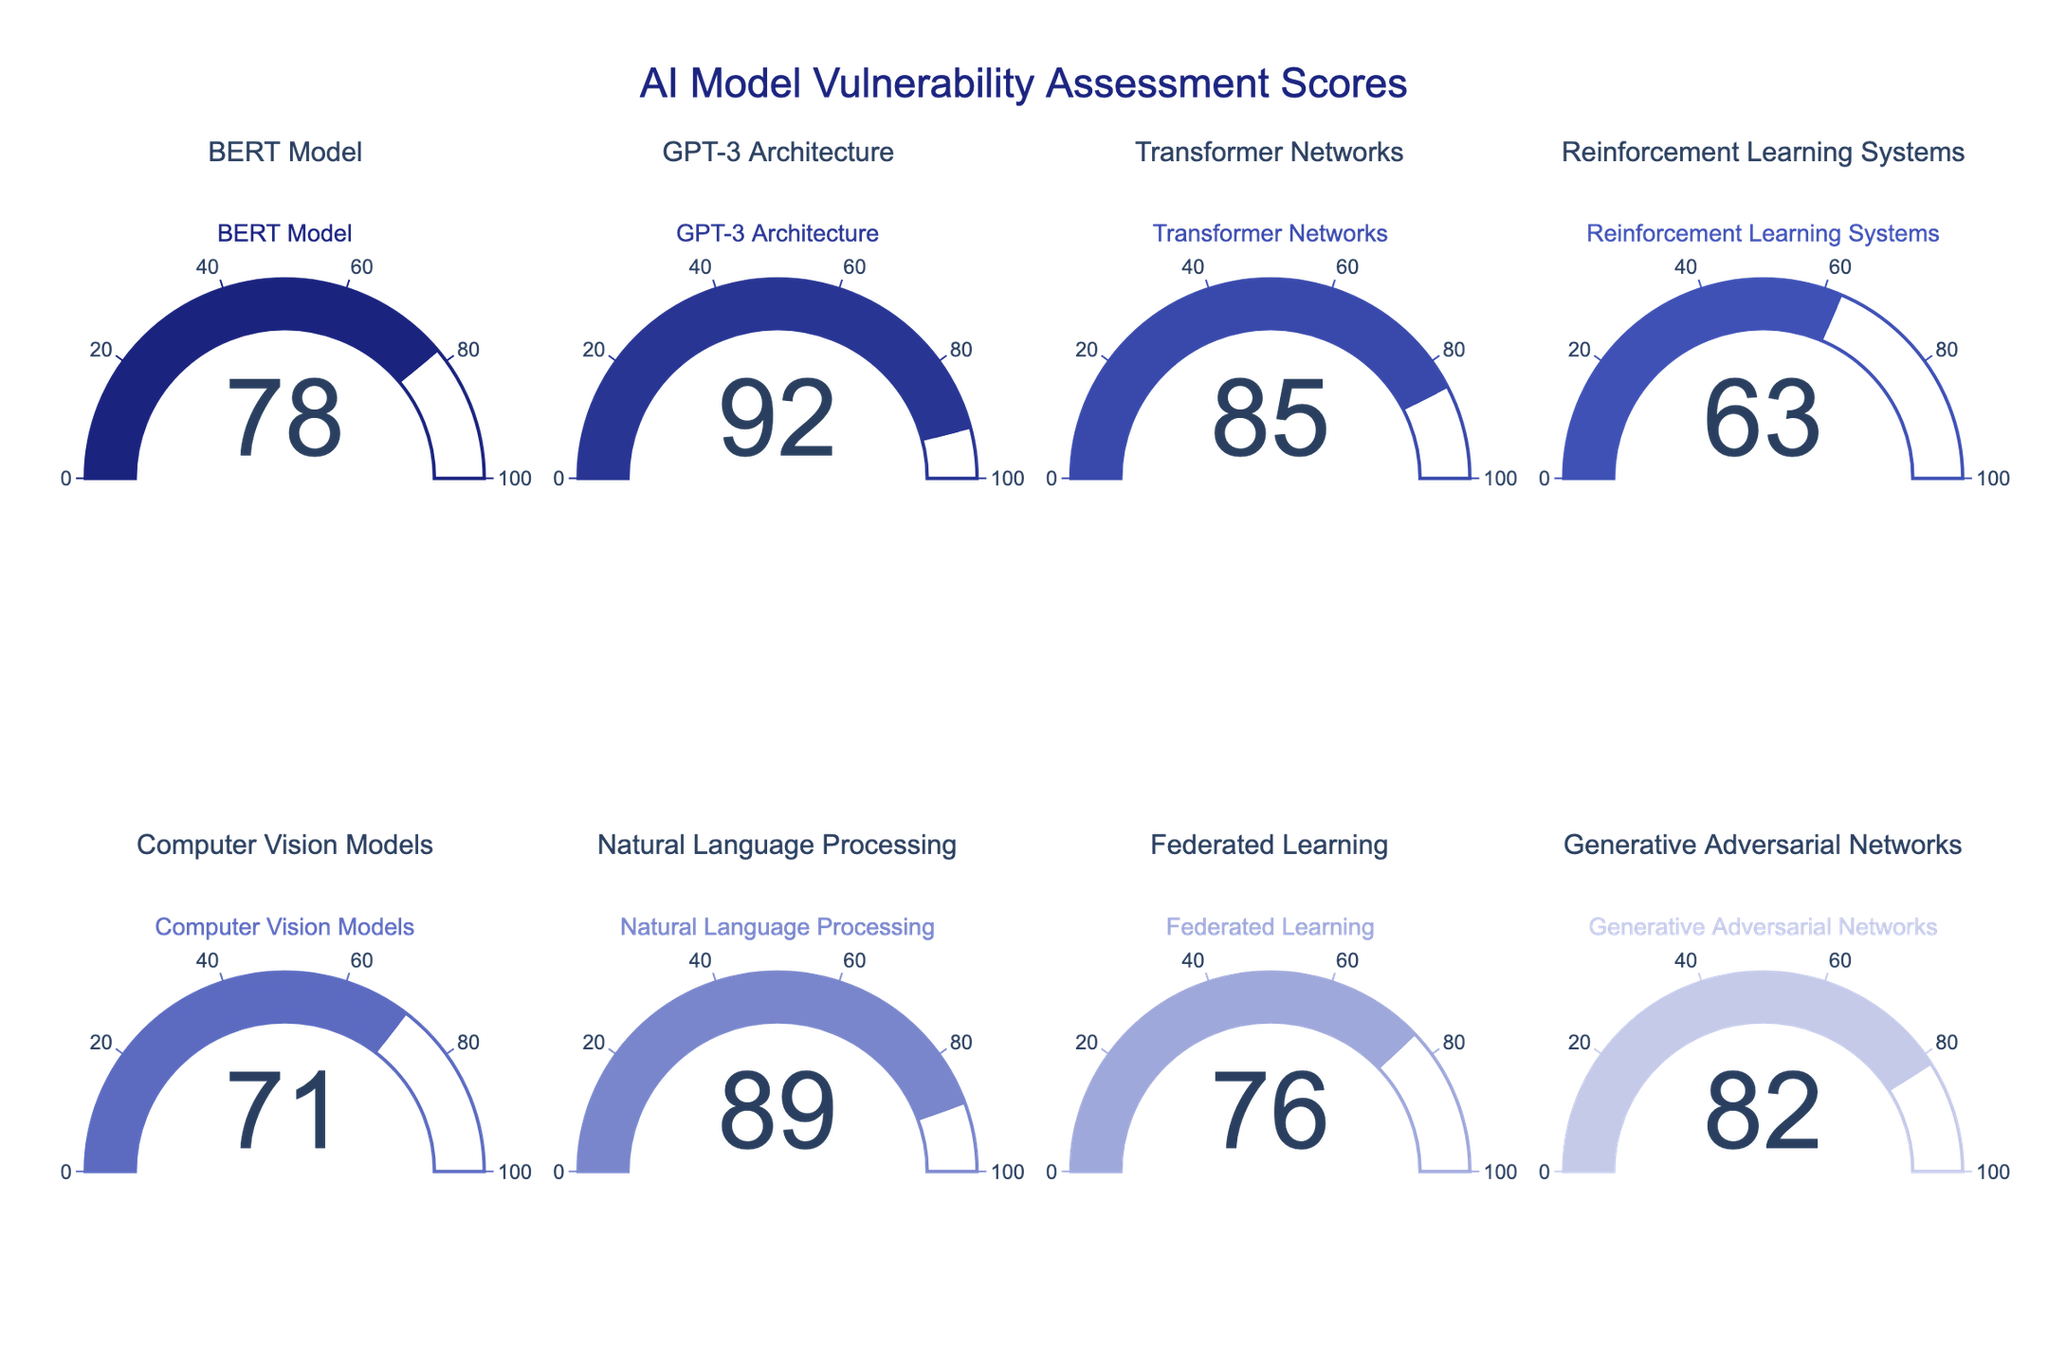What's the title of the figure? The title can be seen at the top of the figure. It is usually positioned centrally and written in a larger font size.
Answer: AI Model Vulnerability Assessment Scores What's the score of the Reinforcement Learning Systems gauge? Look at the gauge corresponding to Reinforcement Learning Systems. The score is displayed as a number within the gauge.
Answer: 63 Which model has the highest vulnerability score? Compare all the numbers displayed within the gauges. The highest number indicates the highest vulnerability score.
Answer: GPT-3 Architecture What is the average vulnerability score of all the models? Add up all the vulnerability scores and divide this sum by the total number of models. The scores are: (78 + 92 + 85 + 63 + 71 + 89 + 76 + 82). Their sum is 636 and dividing by 8 gives the average.
Answer: 79.5 How does the vulnerability score of Natural Language Processing compare to that of Transformer Networks? Locate the scores for both Natural Language Processing and Transformer Networks. Compare the two numbers to see which is higher.
Answer: Natural Language Processing has a higher score Which models have a vulnerability score greater than 80? Identify the models with numbers greater than 80 displayed within the gauges.
Answer: GPT-3 Architecture, Transformer Networks, Natural Language Processing, Generative Adversarial Networks What is the difference in vulnerability score between Computer Vision Models and Federated Learning? Subtract the vulnerability score of Federated Learning from that of Computer Vision Models. Computer Vision Models score 71, and Federated Learning scores 76. So, the difference is 71 - 76.
Answer: -5 Are there any models with a vulnerability score below 70? Look through all the scores and identify any that are below 70.
Answer: Reinforcement Learning Systems Which model has the closest vulnerability score to 80? Identify the model whose vulnerability score is nearest to 80 by comparing how close each value is to this reference number.
Answer: Generative Adversarial Networks 